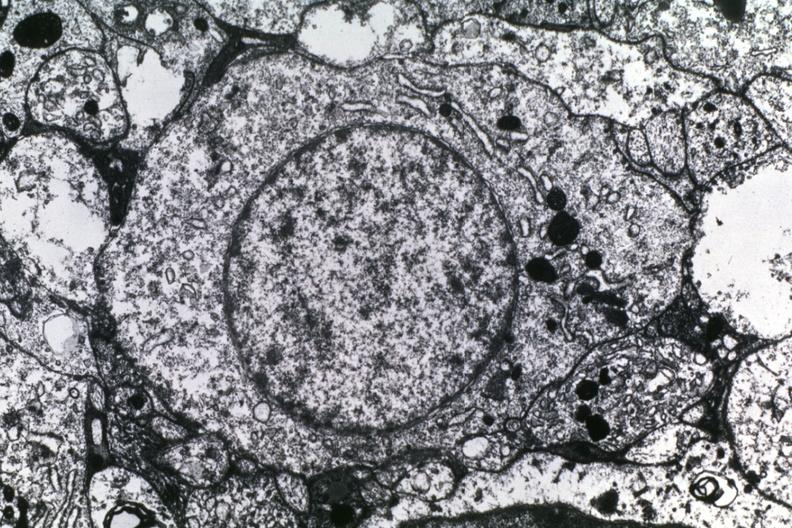what is present?
Answer the question using a single word or phrase. Subependymal giant cell astrocytoma 